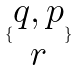Convert formula to latex. <formula><loc_0><loc_0><loc_500><loc_500>\{ \begin{matrix} q , p \\ r \end{matrix} \}</formula> 